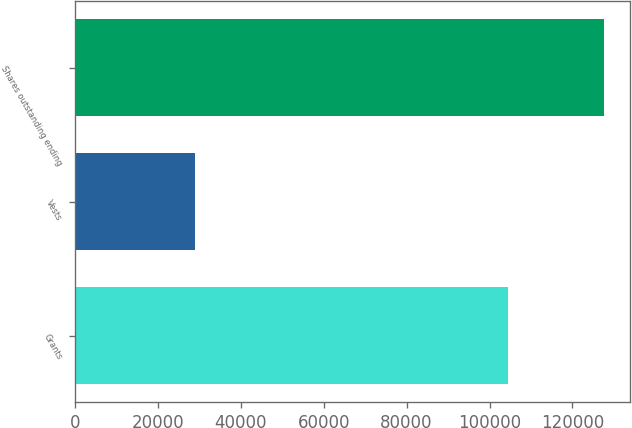Convert chart. <chart><loc_0><loc_0><loc_500><loc_500><bar_chart><fcel>Grants<fcel>Vests<fcel>Shares outstanding ending<nl><fcel>104447<fcel>28842<fcel>127601<nl></chart> 